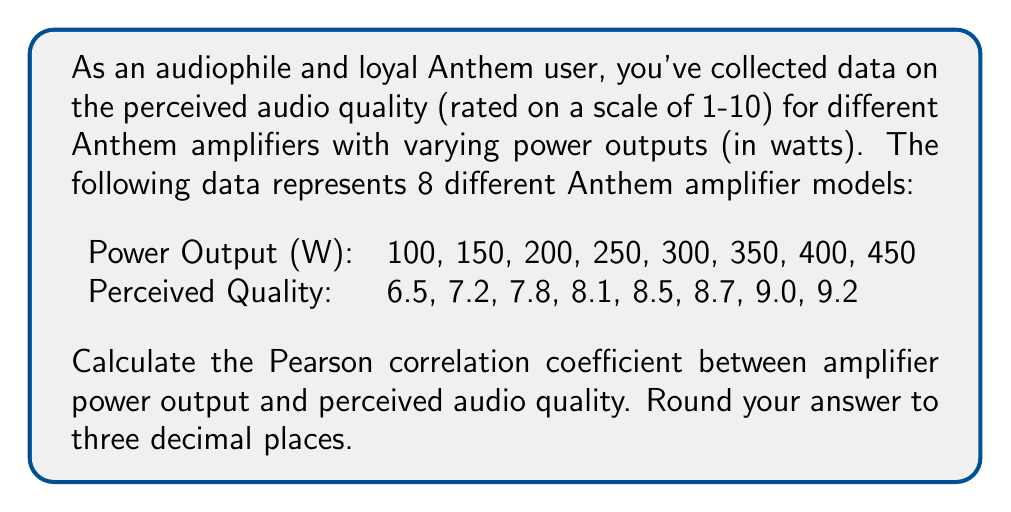Help me with this question. To calculate the Pearson correlation coefficient (r), we'll use the formula:

$$ r = \frac{\sum_{i=1}^{n} (x_i - \bar{x})(y_i - \bar{y})}{\sqrt{\sum_{i=1}^{n} (x_i - \bar{x})^2 \sum_{i=1}^{n} (y_i - \bar{y})^2}} $$

Where:
$x_i$ = Power Output values
$y_i$ = Perceived Quality values
$\bar{x}$ = Mean of Power Output
$\bar{y}$ = Mean of Perceived Quality
$n$ = Number of data points (8)

Step 1: Calculate means
$\bar{x} = \frac{100 + 150 + 200 + 250 + 300 + 350 + 400 + 450}{8} = 275$
$\bar{y} = \frac{6.5 + 7.2 + 7.8 + 8.1 + 8.5 + 8.7 + 9.0 + 9.2}{8} = 8.125$

Step 2: Calculate $(x_i - \bar{x})$, $(y_i - \bar{y})$, $(x_i - \bar{x})^2$, $(y_i - \bar{y})^2$, and $(x_i - \bar{x})(y_i - \bar{y})$

Step 3: Sum the calculated values
$\sum (x_i - \bar{x})(y_i - \bar{y}) = 4743.75$
$\sum (x_i - \bar{x})^2 = 122500$
$\sum (y_i - \bar{y})^2 = 5.59375$

Step 4: Apply the formula
$$ r = \frac{4743.75}{\sqrt{122500 \times 5.59375}} = \frac{4743.75}{826.3191} = 0.5740 $$

Step 5: Round to three decimal places
$r \approx 0.574$
Answer: 0.574 